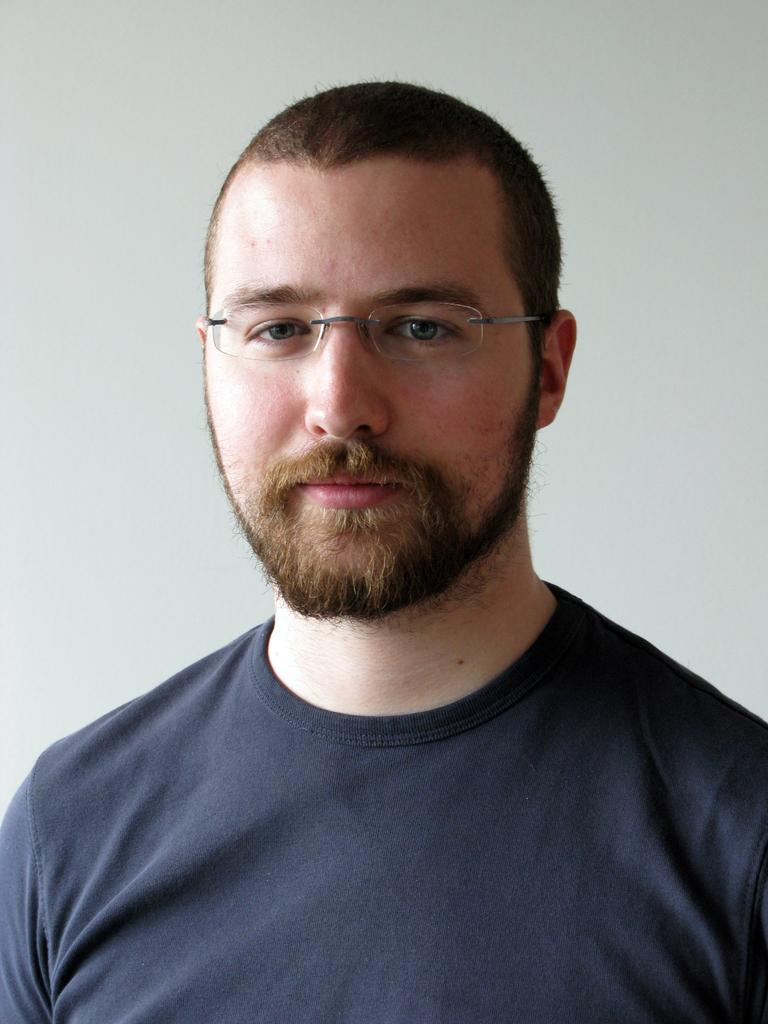Who is present in the image? There is a man in the picture. What is the man wearing in the image? The man is wearing spectacles. What is the color of the background in the image? The background in the image is white. How many fingers does the man's son have in the image? There is no mention of a son in the image, so it is impossible to determine the number of fingers he might have. 